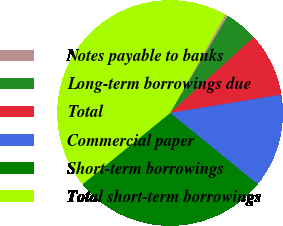<chart> <loc_0><loc_0><loc_500><loc_500><pie_chart><fcel>Notes payable to banks<fcel>Long-term borrowings due<fcel>Total<fcel>Commercial paper<fcel>Short-term borrowings<fcel>Total short-term borrowings<nl><fcel>0.37%<fcel>4.74%<fcel>9.11%<fcel>13.48%<fcel>28.25%<fcel>44.05%<nl></chart> 